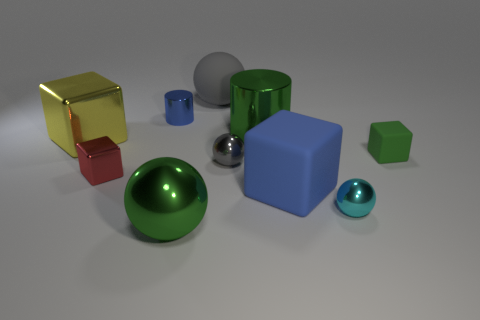Subtract 1 spheres. How many spheres are left? 3 Subtract all balls. How many objects are left? 6 Subtract 0 brown cylinders. How many objects are left? 10 Subtract all tiny green matte cubes. Subtract all cyan metal spheres. How many objects are left? 8 Add 5 tiny gray metal objects. How many tiny gray metal objects are left? 6 Add 9 large yellow cylinders. How many large yellow cylinders exist? 9 